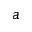Convert formula to latex. <formula><loc_0><loc_0><loc_500><loc_500>a</formula> 